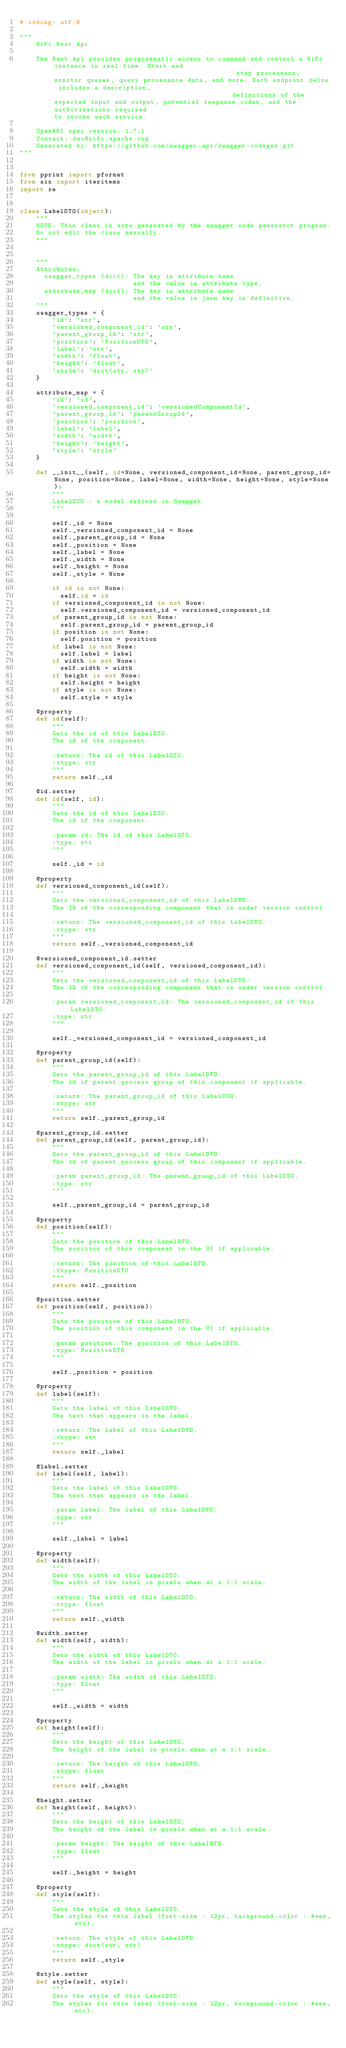Convert code to text. <code><loc_0><loc_0><loc_500><loc_500><_Python_># coding: utf-8

"""
    NiFi Rest Api

    The Rest Api provides programmatic access to command and control a NiFi instance in real time. Start and                                              stop processors, monitor queues, query provenance data, and more. Each endpoint below includes a description,                                             definitions of the expected input and output, potential response codes, and the authorizations required                                             to invoke each service.

    OpenAPI spec version: 1.7.1
    Contact: dev@nifi.apache.org
    Generated by: https://github.com/swagger-api/swagger-codegen.git
"""


from pprint import pformat
from six import iteritems
import re


class LabelDTO(object):
    """
    NOTE: This class is auto generated by the swagger code generator program.
    Do not edit the class manually.
    """


    """
    Attributes:
      swagger_types (dict): The key is attribute name
                            and the value is attribute type.
      attribute_map (dict): The key is attribute name
                            and the value is json key in definition.
    """
    swagger_types = {
        'id': 'str',
        'versioned_component_id': 'str',
        'parent_group_id': 'str',
        'position': 'PositionDTO',
        'label': 'str',
        'width': 'float',
        'height': 'float',
        'style': 'dict(str, str)'
    }

    attribute_map = {
        'id': 'id',
        'versioned_component_id': 'versionedComponentId',
        'parent_group_id': 'parentGroupId',
        'position': 'position',
        'label': 'label',
        'width': 'width',
        'height': 'height',
        'style': 'style'
    }

    def __init__(self, id=None, versioned_component_id=None, parent_group_id=None, position=None, label=None, width=None, height=None, style=None):
        """
        LabelDTO - a model defined in Swagger
        """

        self._id = None
        self._versioned_component_id = None
        self._parent_group_id = None
        self._position = None
        self._label = None
        self._width = None
        self._height = None
        self._style = None

        if id is not None:
          self.id = id
        if versioned_component_id is not None:
          self.versioned_component_id = versioned_component_id
        if parent_group_id is not None:
          self.parent_group_id = parent_group_id
        if position is not None:
          self.position = position
        if label is not None:
          self.label = label
        if width is not None:
          self.width = width
        if height is not None:
          self.height = height
        if style is not None:
          self.style = style

    @property
    def id(self):
        """
        Gets the id of this LabelDTO.
        The id of the component.

        :return: The id of this LabelDTO.
        :rtype: str
        """
        return self._id

    @id.setter
    def id(self, id):
        """
        Sets the id of this LabelDTO.
        The id of the component.

        :param id: The id of this LabelDTO.
        :type: str
        """

        self._id = id

    @property
    def versioned_component_id(self):
        """
        Gets the versioned_component_id of this LabelDTO.
        The ID of the corresponding component that is under version control

        :return: The versioned_component_id of this LabelDTO.
        :rtype: str
        """
        return self._versioned_component_id

    @versioned_component_id.setter
    def versioned_component_id(self, versioned_component_id):
        """
        Sets the versioned_component_id of this LabelDTO.
        The ID of the corresponding component that is under version control

        :param versioned_component_id: The versioned_component_id of this LabelDTO.
        :type: str
        """

        self._versioned_component_id = versioned_component_id

    @property
    def parent_group_id(self):
        """
        Gets the parent_group_id of this LabelDTO.
        The id of parent process group of this component if applicable.

        :return: The parent_group_id of this LabelDTO.
        :rtype: str
        """
        return self._parent_group_id

    @parent_group_id.setter
    def parent_group_id(self, parent_group_id):
        """
        Sets the parent_group_id of this LabelDTO.
        The id of parent process group of this component if applicable.

        :param parent_group_id: The parent_group_id of this LabelDTO.
        :type: str
        """

        self._parent_group_id = parent_group_id

    @property
    def position(self):
        """
        Gets the position of this LabelDTO.
        The position of this component in the UI if applicable.

        :return: The position of this LabelDTO.
        :rtype: PositionDTO
        """
        return self._position

    @position.setter
    def position(self, position):
        """
        Sets the position of this LabelDTO.
        The position of this component in the UI if applicable.

        :param position: The position of this LabelDTO.
        :type: PositionDTO
        """

        self._position = position

    @property
    def label(self):
        """
        Gets the label of this LabelDTO.
        The text that appears in the label.

        :return: The label of this LabelDTO.
        :rtype: str
        """
        return self._label

    @label.setter
    def label(self, label):
        """
        Sets the label of this LabelDTO.
        The text that appears in the label.

        :param label: The label of this LabelDTO.
        :type: str
        """

        self._label = label

    @property
    def width(self):
        """
        Gets the width of this LabelDTO.
        The width of the label in pixels when at a 1:1 scale.

        :return: The width of this LabelDTO.
        :rtype: float
        """
        return self._width

    @width.setter
    def width(self, width):
        """
        Sets the width of this LabelDTO.
        The width of the label in pixels when at a 1:1 scale.

        :param width: The width of this LabelDTO.
        :type: float
        """

        self._width = width

    @property
    def height(self):
        """
        Gets the height of this LabelDTO.
        The height of the label in pixels when at a 1:1 scale.

        :return: The height of this LabelDTO.
        :rtype: float
        """
        return self._height

    @height.setter
    def height(self, height):
        """
        Sets the height of this LabelDTO.
        The height of the label in pixels when at a 1:1 scale.

        :param height: The height of this LabelDTO.
        :type: float
        """

        self._height = height

    @property
    def style(self):
        """
        Gets the style of this LabelDTO.
        The styles for this label (font-size : 12px, background-color : #eee, etc).

        :return: The style of this LabelDTO.
        :rtype: dict(str, str)
        """
        return self._style

    @style.setter
    def style(self, style):
        """
        Sets the style of this LabelDTO.
        The styles for this label (font-size : 12px, background-color : #eee, etc).
</code> 